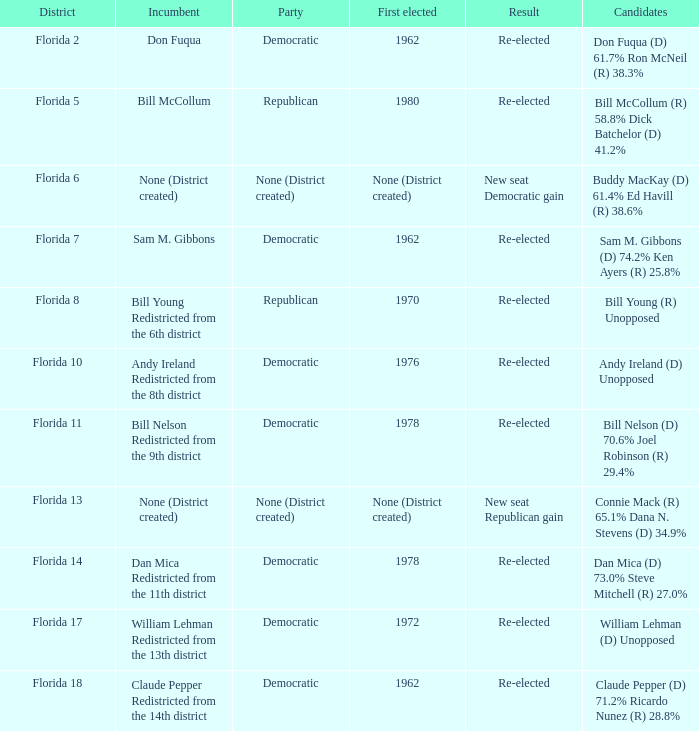What was the first elected position in florida's 7th district? 1962.0. 